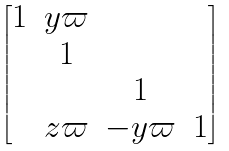<formula> <loc_0><loc_0><loc_500><loc_500>\begin{bmatrix} 1 & y \varpi \\ & 1 \\ & & 1 \\ & z \varpi & - y \varpi & 1 \end{bmatrix}</formula> 